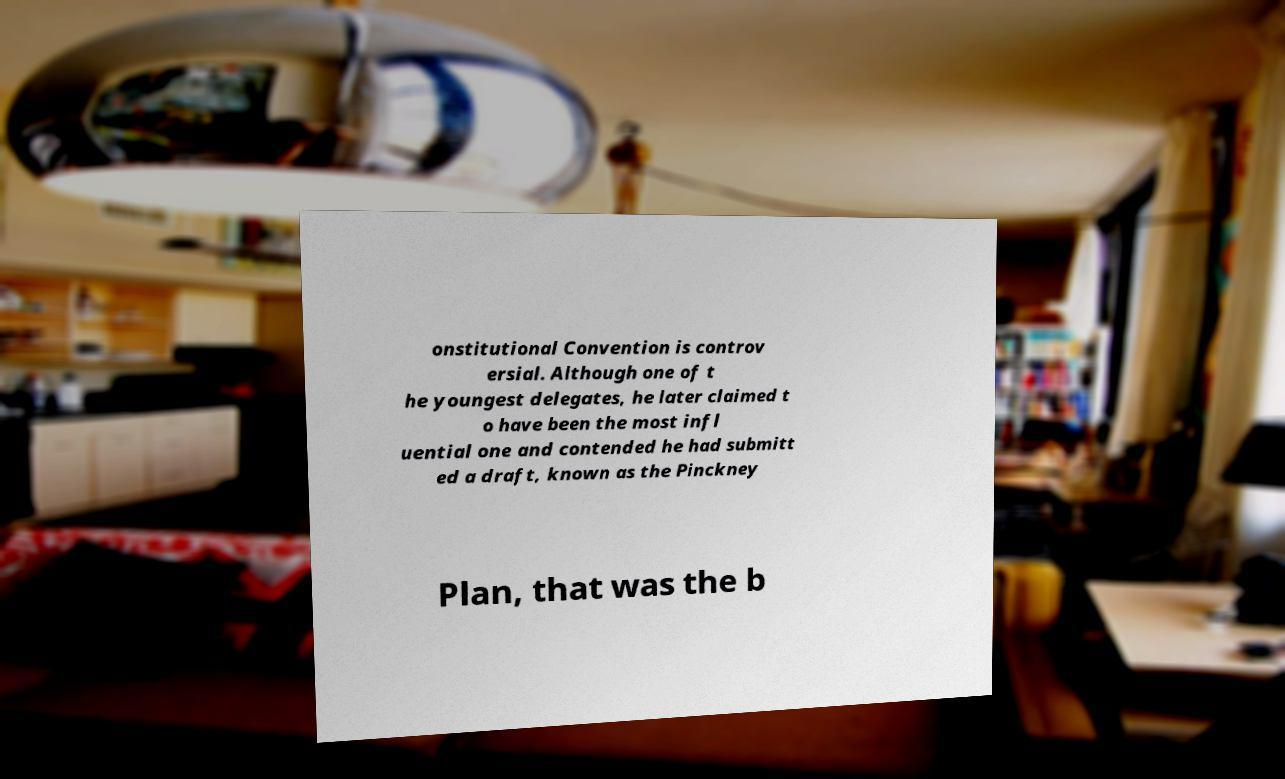Could you extract and type out the text from this image? onstitutional Convention is controv ersial. Although one of t he youngest delegates, he later claimed t o have been the most infl uential one and contended he had submitt ed a draft, known as the Pinckney Plan, that was the b 